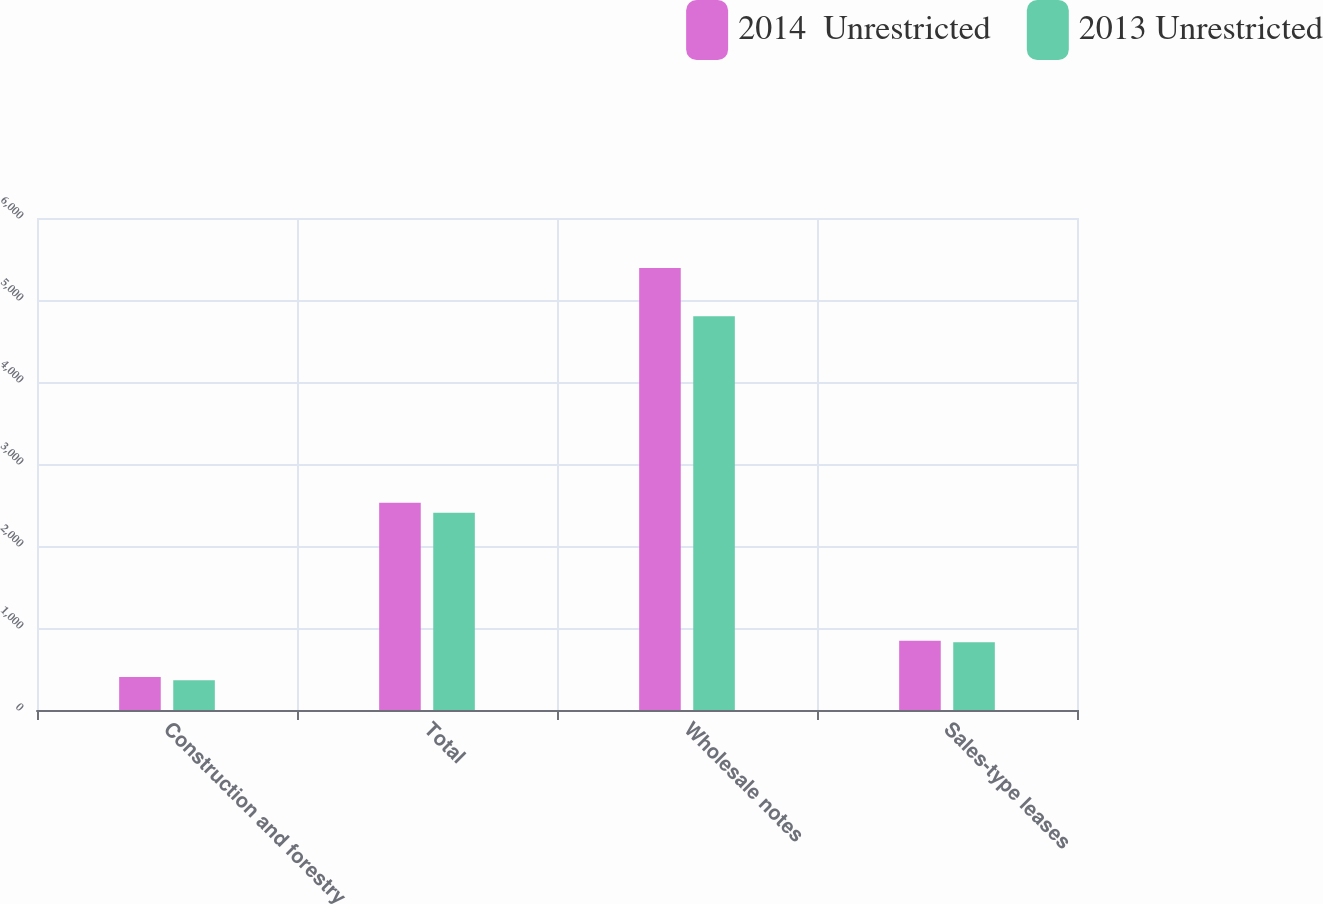Convert chart. <chart><loc_0><loc_0><loc_500><loc_500><stacked_bar_chart><ecel><fcel>Construction and forestry<fcel>Total<fcel>Wholesale notes<fcel>Sales-type leases<nl><fcel>2014  Unrestricted<fcel>403<fcel>2528<fcel>5390<fcel>844<nl><fcel>2013 Unrestricted<fcel>364<fcel>2406<fcel>4802<fcel>826<nl></chart> 